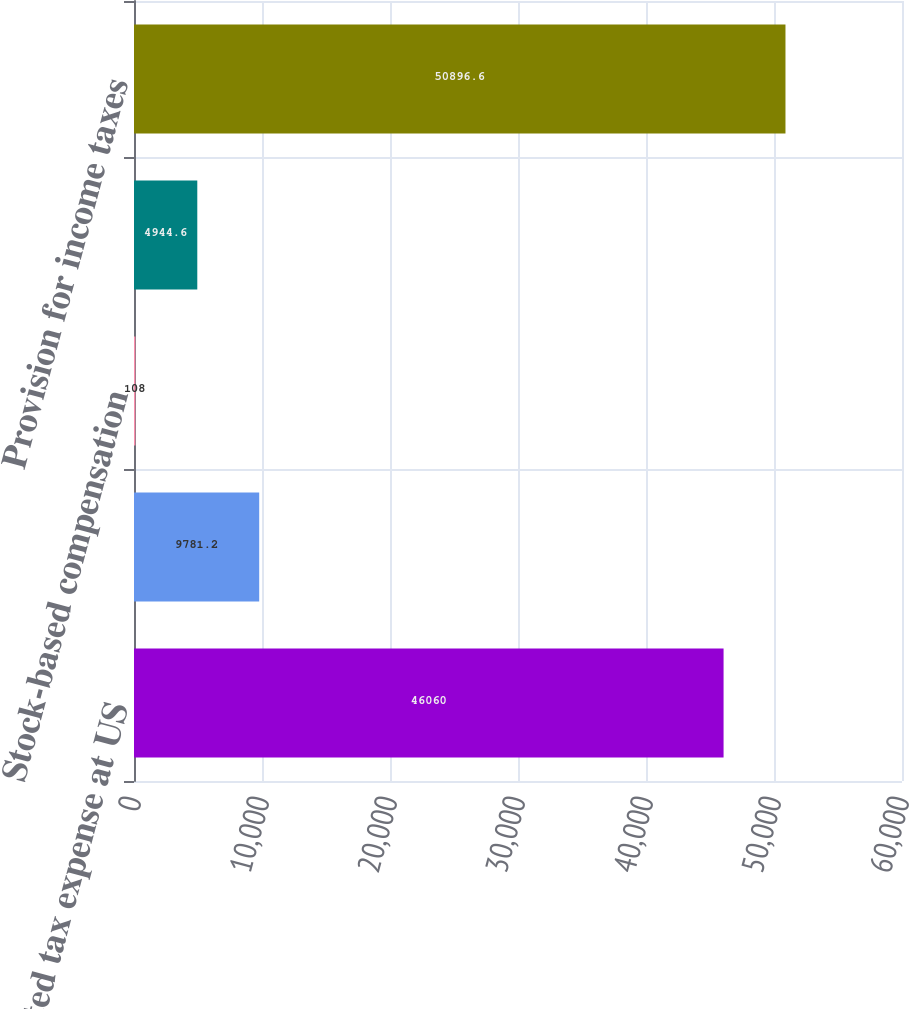Convert chart. <chart><loc_0><loc_0><loc_500><loc_500><bar_chart><fcel>Expected tax expense at US<fcel>State income taxes net of<fcel>Stock-based compensation<fcel>Other<fcel>Provision for income taxes<nl><fcel>46060<fcel>9781.2<fcel>108<fcel>4944.6<fcel>50896.6<nl></chart> 